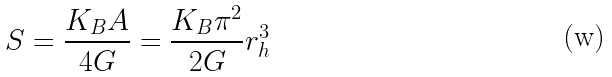<formula> <loc_0><loc_0><loc_500><loc_500>S = \frac { K _ { B } A } { 4 G } = \frac { K _ { B } \pi ^ { 2 } } { 2 G } r _ { h } ^ { 3 }</formula> 